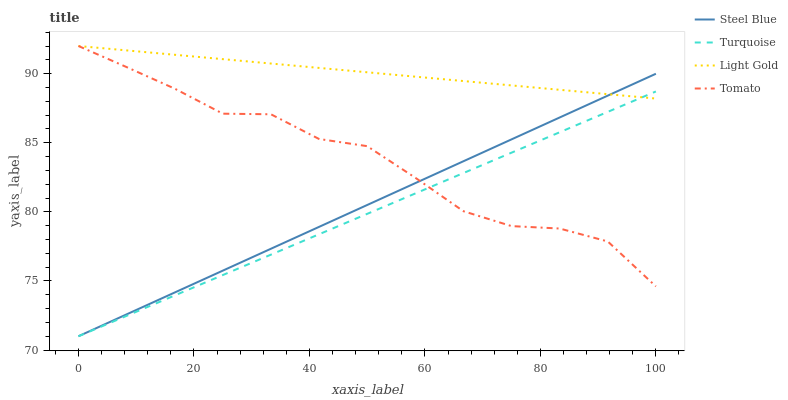Does Turquoise have the minimum area under the curve?
Answer yes or no. Yes. Does Light Gold have the maximum area under the curve?
Answer yes or no. Yes. Does Light Gold have the minimum area under the curve?
Answer yes or no. No. Does Turquoise have the maximum area under the curve?
Answer yes or no. No. Is Turquoise the smoothest?
Answer yes or no. Yes. Is Tomato the roughest?
Answer yes or no. Yes. Is Light Gold the smoothest?
Answer yes or no. No. Is Light Gold the roughest?
Answer yes or no. No. Does Light Gold have the lowest value?
Answer yes or no. No. Does Light Gold have the highest value?
Answer yes or no. Yes. Does Turquoise have the highest value?
Answer yes or no. No. Does Turquoise intersect Light Gold?
Answer yes or no. Yes. Is Turquoise less than Light Gold?
Answer yes or no. No. Is Turquoise greater than Light Gold?
Answer yes or no. No. 